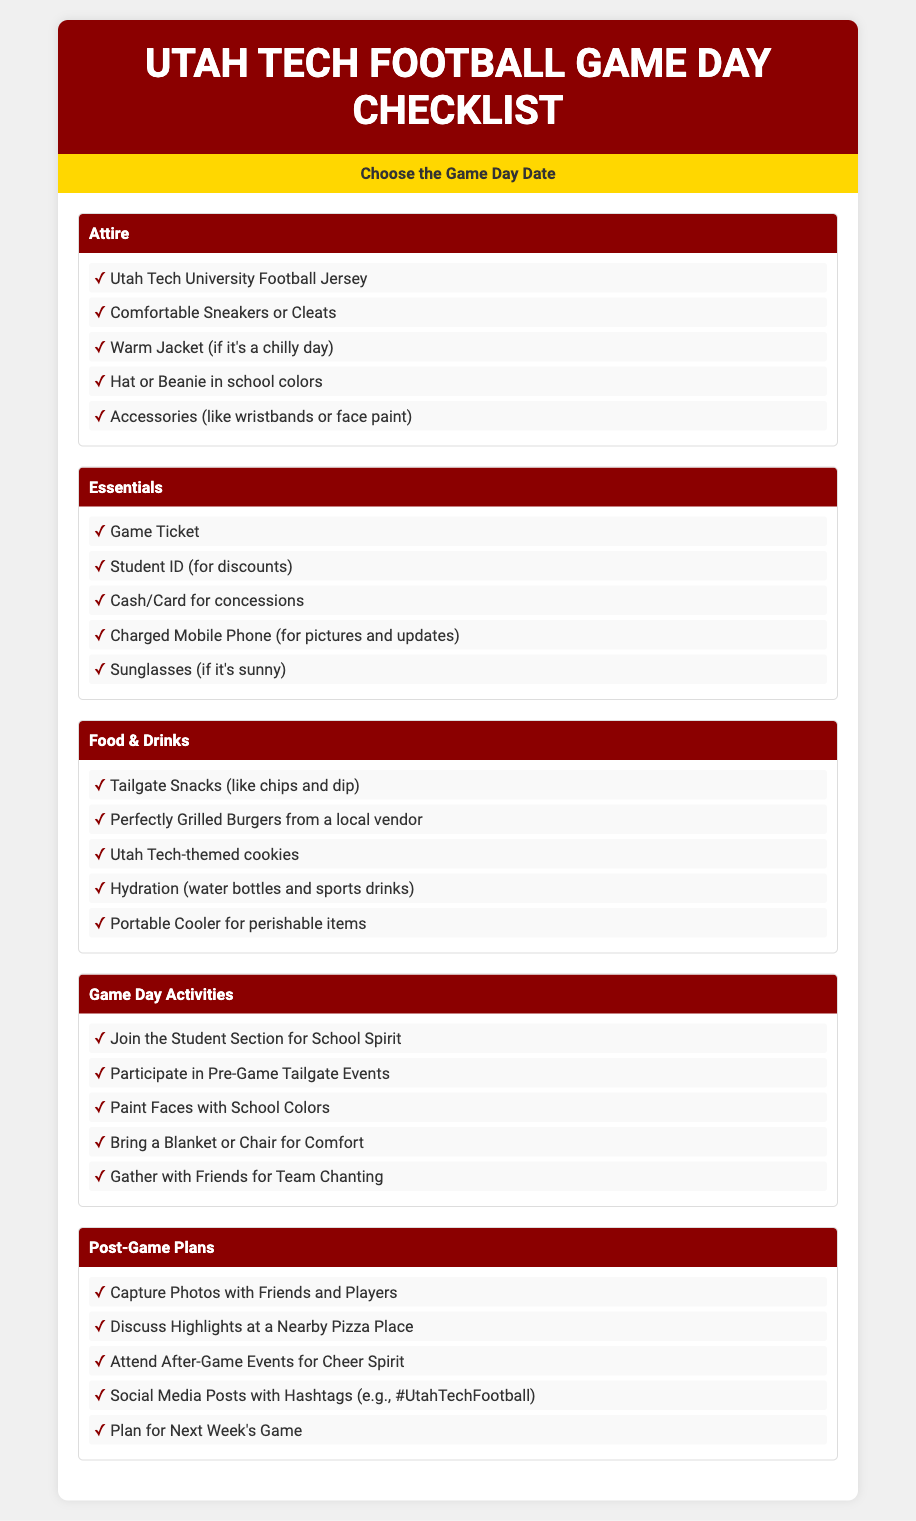What is the title of the checklist? The title of the checklist is prominently displayed at the top of the document.
Answer: Utah Tech Football Game Day Checklist How many categories are in the checklist? The checklist includes five distinct categories.
Answer: 5 What should you wear on game day? The "Attire" category lists specific clothing items for game day.
Answer: Utah Tech University Football Jersey What is recommended for hydration? The "Food & Drinks" category suggests what to drink on game day.
Answer: water bottles and sports drinks What is a post-game plan mentioned? The "Post-Game Plans" category outlines specific activities after the game.
Answer: Capture Photos with Friends and Players What is one item listed under Essentials? This category includes essential items needed on game day.
Answer: Game Ticket What activity involves joining the student section? The "Game Day Activities" category mentions a specific school spirit activity.
Answer: Join the Student Section for School Spirit What color should the hat or beanie be? The attire guidelines suggest specific colors related to school spirit.
Answer: school colors What should be included in the tailgate snacks? The "Food & Drinks" category lists items for tailgating.
Answer: chips and dip 